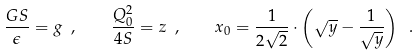<formula> <loc_0><loc_0><loc_500><loc_500>\frac { G S } { \epsilon } = g \ , \quad \frac { Q _ { 0 } ^ { 2 } } { 4 S } = z \ , \quad x _ { 0 } = \frac { 1 } { 2 \sqrt { 2 } } \cdot \left ( \sqrt { y } - \frac { 1 } { \sqrt { y } } \right ) \ .</formula> 